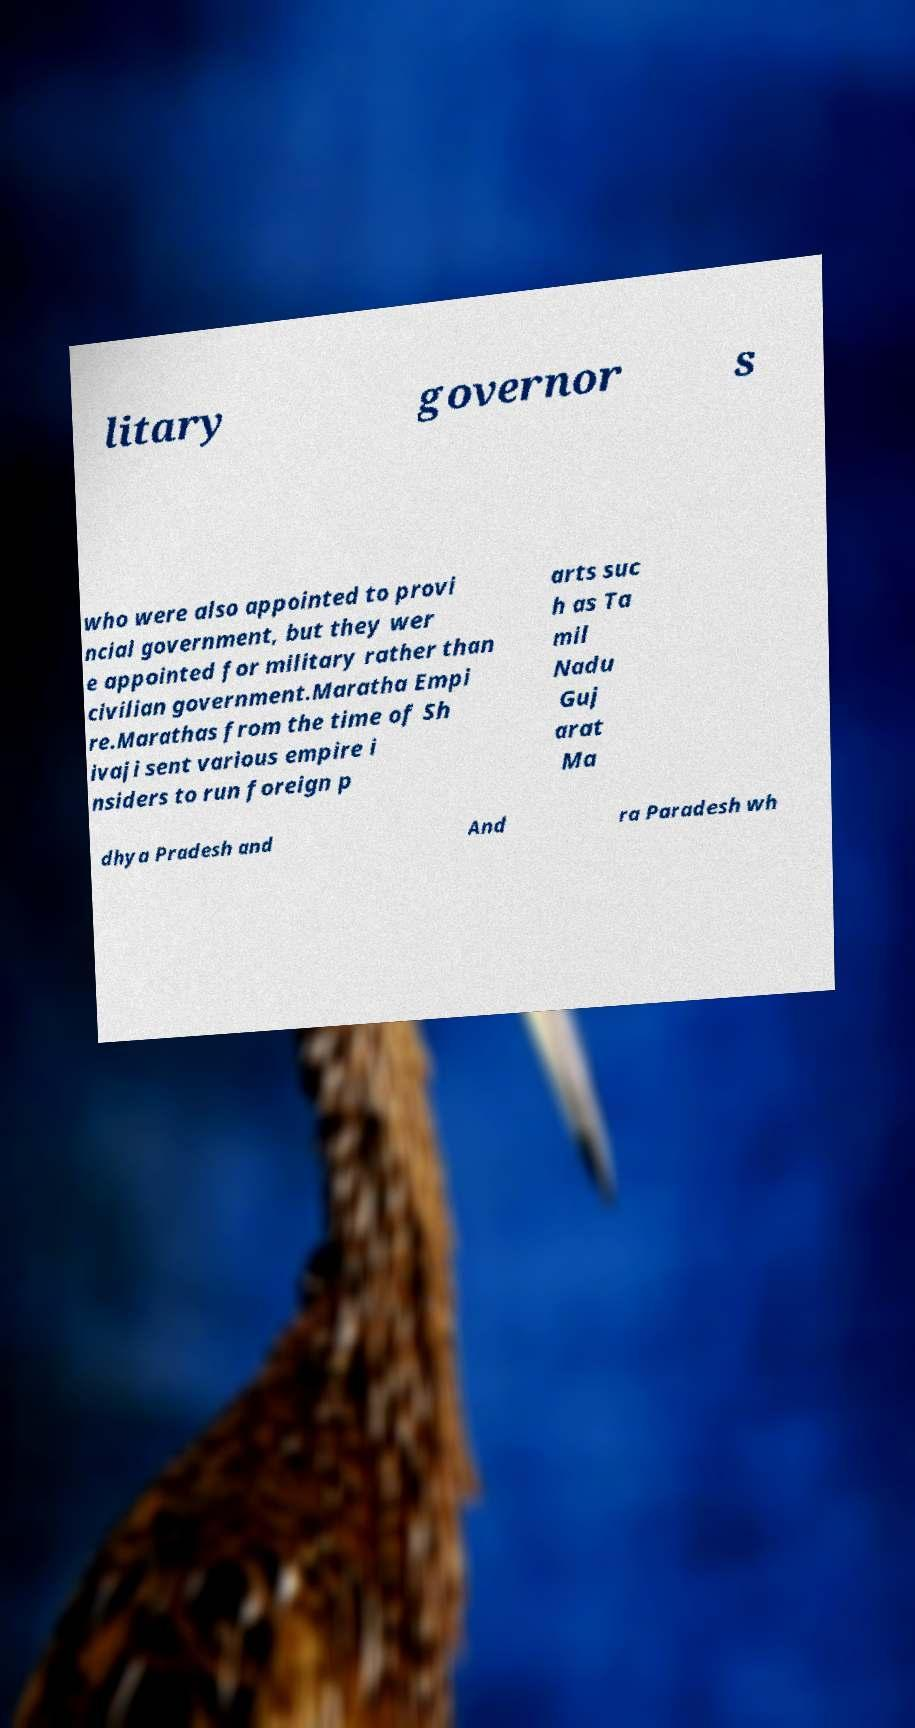I need the written content from this picture converted into text. Can you do that? litary governor s who were also appointed to provi ncial government, but they wer e appointed for military rather than civilian government.Maratha Empi re.Marathas from the time of Sh ivaji sent various empire i nsiders to run foreign p arts suc h as Ta mil Nadu Guj arat Ma dhya Pradesh and And ra Paradesh wh 